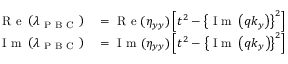<formula> <loc_0><loc_0><loc_500><loc_500>\begin{array} { r l } { R e \left ( \lambda _ { P B C } \right ) } & = R e ( \eta _ { y y } ) \left [ t ^ { 2 } - \left \{ I m \left ( q k _ { y } \right ) \right \} ^ { 2 } \right ] } \\ { I m \left ( \lambda _ { P B C } \right ) } & = I m ( \eta _ { y y } ) \left [ t ^ { 2 } - \left \{ I m \left ( q k _ { y } \right ) \right \} ^ { 2 } \right ] } \end{array}</formula> 